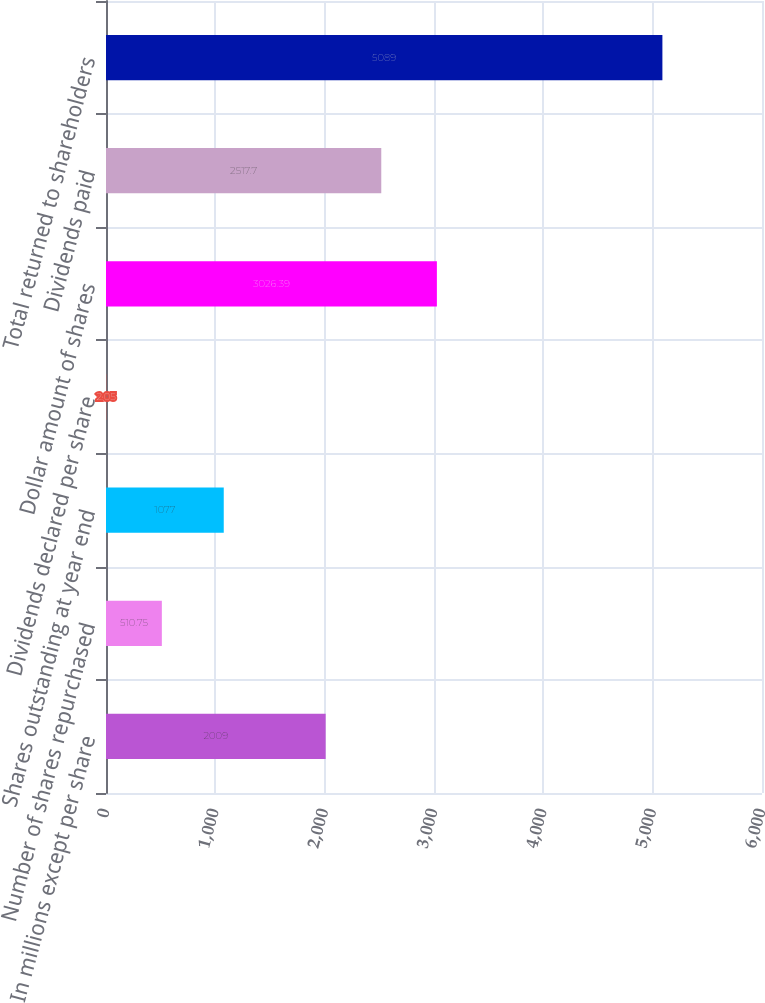<chart> <loc_0><loc_0><loc_500><loc_500><bar_chart><fcel>In millions except per share<fcel>Number of shares repurchased<fcel>Shares outstanding at year end<fcel>Dividends declared per share<fcel>Dollar amount of shares<fcel>Dividends paid<fcel>Total returned to shareholders<nl><fcel>2009<fcel>510.75<fcel>1077<fcel>2.05<fcel>3026.39<fcel>2517.7<fcel>5089<nl></chart> 